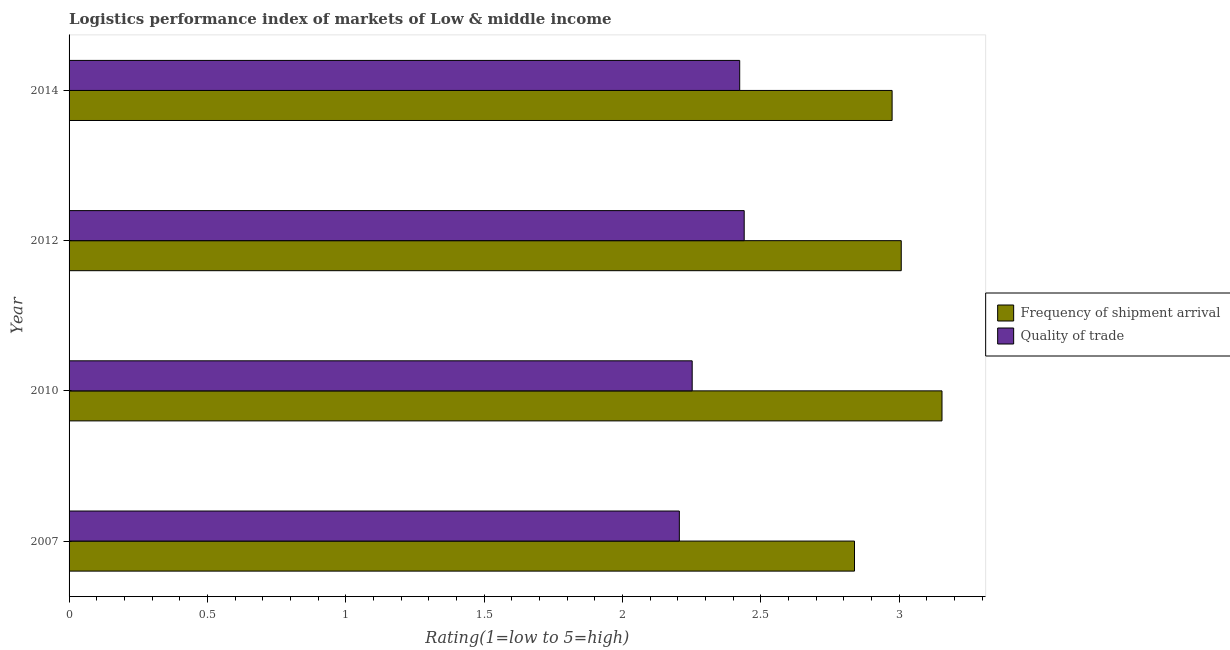How many different coloured bars are there?
Your answer should be compact. 2. How many groups of bars are there?
Your response must be concise. 4. Are the number of bars per tick equal to the number of legend labels?
Make the answer very short. Yes. How many bars are there on the 1st tick from the top?
Your response must be concise. 2. How many bars are there on the 4th tick from the bottom?
Keep it short and to the point. 2. What is the lpi quality of trade in 2010?
Give a very brief answer. 2.25. Across all years, what is the maximum lpi quality of trade?
Your answer should be compact. 2.44. Across all years, what is the minimum lpi quality of trade?
Provide a short and direct response. 2.21. In which year was the lpi quality of trade maximum?
Provide a short and direct response. 2012. What is the total lpi quality of trade in the graph?
Keep it short and to the point. 9.32. What is the difference between the lpi quality of trade in 2007 and that in 2014?
Ensure brevity in your answer.  -0.22. What is the difference between the lpi quality of trade in 2010 and the lpi of frequency of shipment arrival in 2014?
Provide a short and direct response. -0.72. What is the average lpi quality of trade per year?
Offer a terse response. 2.33. In the year 2007, what is the difference between the lpi quality of trade and lpi of frequency of shipment arrival?
Keep it short and to the point. -0.63. In how many years, is the lpi of frequency of shipment arrival greater than 0.2 ?
Give a very brief answer. 4. Is the difference between the lpi quality of trade in 2007 and 2012 greater than the difference between the lpi of frequency of shipment arrival in 2007 and 2012?
Provide a short and direct response. No. What is the difference between the highest and the second highest lpi quality of trade?
Offer a very short reply. 0.02. What is the difference between the highest and the lowest lpi quality of trade?
Offer a terse response. 0.23. Is the sum of the lpi of frequency of shipment arrival in 2010 and 2014 greater than the maximum lpi quality of trade across all years?
Keep it short and to the point. Yes. What does the 2nd bar from the top in 2012 represents?
Make the answer very short. Frequency of shipment arrival. What does the 2nd bar from the bottom in 2012 represents?
Your response must be concise. Quality of trade. How many years are there in the graph?
Give a very brief answer. 4. What is the difference between two consecutive major ticks on the X-axis?
Keep it short and to the point. 0.5. Are the values on the major ticks of X-axis written in scientific E-notation?
Offer a very short reply. No. What is the title of the graph?
Provide a short and direct response. Logistics performance index of markets of Low & middle income. What is the label or title of the X-axis?
Offer a very short reply. Rating(1=low to 5=high). What is the label or title of the Y-axis?
Provide a short and direct response. Year. What is the Rating(1=low to 5=high) in Frequency of shipment arrival in 2007?
Your answer should be very brief. 2.84. What is the Rating(1=low to 5=high) in Quality of trade in 2007?
Ensure brevity in your answer.  2.21. What is the Rating(1=low to 5=high) of Frequency of shipment arrival in 2010?
Your answer should be compact. 3.16. What is the Rating(1=low to 5=high) in Quality of trade in 2010?
Provide a short and direct response. 2.25. What is the Rating(1=low to 5=high) in Frequency of shipment arrival in 2012?
Your response must be concise. 3.01. What is the Rating(1=low to 5=high) in Quality of trade in 2012?
Your response must be concise. 2.44. What is the Rating(1=low to 5=high) of Frequency of shipment arrival in 2014?
Offer a very short reply. 2.98. What is the Rating(1=low to 5=high) in Quality of trade in 2014?
Make the answer very short. 2.42. Across all years, what is the maximum Rating(1=low to 5=high) in Frequency of shipment arrival?
Your answer should be very brief. 3.16. Across all years, what is the maximum Rating(1=low to 5=high) in Quality of trade?
Your answer should be compact. 2.44. Across all years, what is the minimum Rating(1=low to 5=high) in Frequency of shipment arrival?
Provide a short and direct response. 2.84. Across all years, what is the minimum Rating(1=low to 5=high) of Quality of trade?
Make the answer very short. 2.21. What is the total Rating(1=low to 5=high) in Frequency of shipment arrival in the graph?
Provide a succinct answer. 11.98. What is the total Rating(1=low to 5=high) in Quality of trade in the graph?
Offer a terse response. 9.32. What is the difference between the Rating(1=low to 5=high) in Frequency of shipment arrival in 2007 and that in 2010?
Offer a very short reply. -0.32. What is the difference between the Rating(1=low to 5=high) in Quality of trade in 2007 and that in 2010?
Offer a terse response. -0.05. What is the difference between the Rating(1=low to 5=high) in Frequency of shipment arrival in 2007 and that in 2012?
Offer a terse response. -0.17. What is the difference between the Rating(1=low to 5=high) of Quality of trade in 2007 and that in 2012?
Give a very brief answer. -0.23. What is the difference between the Rating(1=low to 5=high) in Frequency of shipment arrival in 2007 and that in 2014?
Offer a terse response. -0.14. What is the difference between the Rating(1=low to 5=high) of Quality of trade in 2007 and that in 2014?
Ensure brevity in your answer.  -0.22. What is the difference between the Rating(1=low to 5=high) of Frequency of shipment arrival in 2010 and that in 2012?
Your answer should be compact. 0.15. What is the difference between the Rating(1=low to 5=high) in Quality of trade in 2010 and that in 2012?
Your answer should be compact. -0.19. What is the difference between the Rating(1=low to 5=high) in Frequency of shipment arrival in 2010 and that in 2014?
Provide a short and direct response. 0.18. What is the difference between the Rating(1=low to 5=high) in Quality of trade in 2010 and that in 2014?
Your response must be concise. -0.17. What is the difference between the Rating(1=low to 5=high) in Frequency of shipment arrival in 2012 and that in 2014?
Your response must be concise. 0.03. What is the difference between the Rating(1=low to 5=high) of Quality of trade in 2012 and that in 2014?
Your answer should be compact. 0.02. What is the difference between the Rating(1=low to 5=high) of Frequency of shipment arrival in 2007 and the Rating(1=low to 5=high) of Quality of trade in 2010?
Your answer should be compact. 0.59. What is the difference between the Rating(1=low to 5=high) in Frequency of shipment arrival in 2007 and the Rating(1=low to 5=high) in Quality of trade in 2012?
Keep it short and to the point. 0.4. What is the difference between the Rating(1=low to 5=high) of Frequency of shipment arrival in 2007 and the Rating(1=low to 5=high) of Quality of trade in 2014?
Your response must be concise. 0.41. What is the difference between the Rating(1=low to 5=high) in Frequency of shipment arrival in 2010 and the Rating(1=low to 5=high) in Quality of trade in 2012?
Provide a succinct answer. 0.71. What is the difference between the Rating(1=low to 5=high) of Frequency of shipment arrival in 2010 and the Rating(1=low to 5=high) of Quality of trade in 2014?
Your answer should be compact. 0.73. What is the difference between the Rating(1=low to 5=high) in Frequency of shipment arrival in 2012 and the Rating(1=low to 5=high) in Quality of trade in 2014?
Your answer should be very brief. 0.58. What is the average Rating(1=low to 5=high) of Frequency of shipment arrival per year?
Ensure brevity in your answer.  2.99. What is the average Rating(1=low to 5=high) of Quality of trade per year?
Ensure brevity in your answer.  2.33. In the year 2007, what is the difference between the Rating(1=low to 5=high) in Frequency of shipment arrival and Rating(1=low to 5=high) in Quality of trade?
Your response must be concise. 0.63. In the year 2010, what is the difference between the Rating(1=low to 5=high) of Frequency of shipment arrival and Rating(1=low to 5=high) of Quality of trade?
Provide a succinct answer. 0.9. In the year 2012, what is the difference between the Rating(1=low to 5=high) in Frequency of shipment arrival and Rating(1=low to 5=high) in Quality of trade?
Offer a very short reply. 0.57. In the year 2014, what is the difference between the Rating(1=low to 5=high) of Frequency of shipment arrival and Rating(1=low to 5=high) of Quality of trade?
Provide a short and direct response. 0.55. What is the ratio of the Rating(1=low to 5=high) of Frequency of shipment arrival in 2007 to that in 2010?
Your answer should be compact. 0.9. What is the ratio of the Rating(1=low to 5=high) in Quality of trade in 2007 to that in 2010?
Give a very brief answer. 0.98. What is the ratio of the Rating(1=low to 5=high) in Frequency of shipment arrival in 2007 to that in 2012?
Ensure brevity in your answer.  0.94. What is the ratio of the Rating(1=low to 5=high) of Quality of trade in 2007 to that in 2012?
Provide a short and direct response. 0.9. What is the ratio of the Rating(1=low to 5=high) of Frequency of shipment arrival in 2007 to that in 2014?
Offer a very short reply. 0.95. What is the ratio of the Rating(1=low to 5=high) in Quality of trade in 2007 to that in 2014?
Offer a terse response. 0.91. What is the ratio of the Rating(1=low to 5=high) in Frequency of shipment arrival in 2010 to that in 2012?
Your answer should be compact. 1.05. What is the ratio of the Rating(1=low to 5=high) in Quality of trade in 2010 to that in 2012?
Your response must be concise. 0.92. What is the ratio of the Rating(1=low to 5=high) in Frequency of shipment arrival in 2010 to that in 2014?
Offer a very short reply. 1.06. What is the ratio of the Rating(1=low to 5=high) of Quality of trade in 2010 to that in 2014?
Provide a succinct answer. 0.93. What is the ratio of the Rating(1=low to 5=high) in Frequency of shipment arrival in 2012 to that in 2014?
Your answer should be very brief. 1.01. What is the ratio of the Rating(1=low to 5=high) in Quality of trade in 2012 to that in 2014?
Make the answer very short. 1.01. What is the difference between the highest and the second highest Rating(1=low to 5=high) in Frequency of shipment arrival?
Your response must be concise. 0.15. What is the difference between the highest and the second highest Rating(1=low to 5=high) in Quality of trade?
Provide a succinct answer. 0.02. What is the difference between the highest and the lowest Rating(1=low to 5=high) of Frequency of shipment arrival?
Ensure brevity in your answer.  0.32. What is the difference between the highest and the lowest Rating(1=low to 5=high) of Quality of trade?
Your answer should be compact. 0.23. 